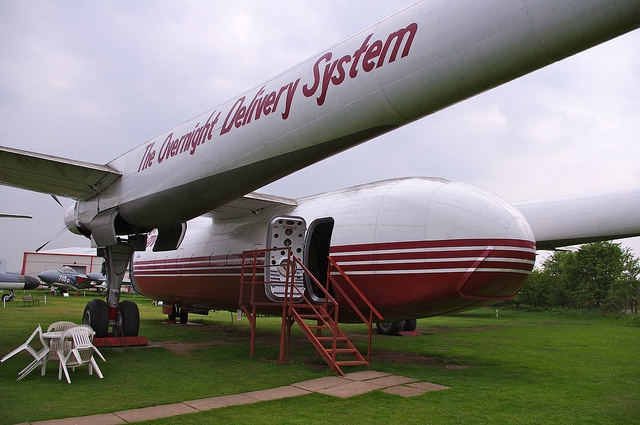Describe the objects in this image and their specific colors. I can see airplane in lavender, black, darkgray, and gray tones, chair in lavender, black, darkgray, gray, and lightgray tones, airplane in lavender, black, darkgray, and gray tones, chair in lavender, black, darkgray, gray, and lightgray tones, and airplane in lavender, black, and gray tones in this image. 